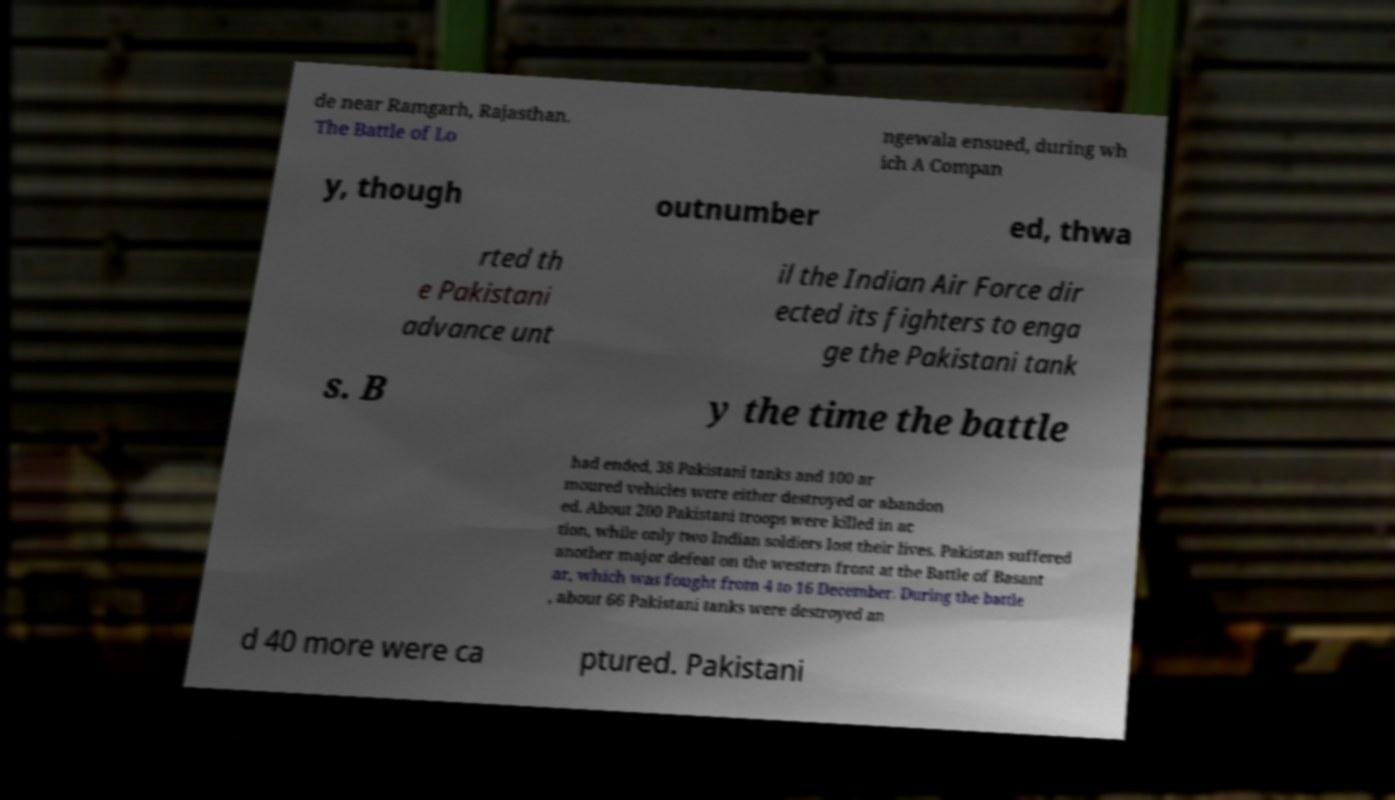There's text embedded in this image that I need extracted. Can you transcribe it verbatim? de near Ramgarh, Rajasthan. The Battle of Lo ngewala ensued, during wh ich A Compan y, though outnumber ed, thwa rted th e Pakistani advance unt il the Indian Air Force dir ected its fighters to enga ge the Pakistani tank s. B y the time the battle had ended, 38 Pakistani tanks and 100 ar moured vehicles were either destroyed or abandon ed. About 200 Pakistani troops were killed in ac tion, while only two Indian soldiers lost their lives. Pakistan suffered another major defeat on the western front at the Battle of Basant ar, which was fought from 4 to 16 December. During the battle , about 66 Pakistani tanks were destroyed an d 40 more were ca ptured. Pakistani 